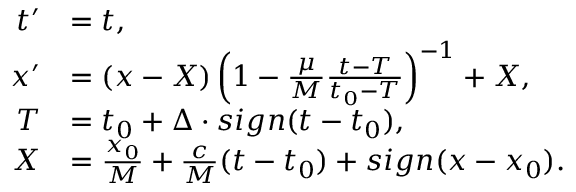Convert formula to latex. <formula><loc_0><loc_0><loc_500><loc_500>\begin{array} { r l } { t ^ { \prime } } & { = t , } \\ { x ^ { \prime } } & { = \left ( x - X \right ) \left ( 1 - \frac { \mu } { M } \frac { t - T } { t _ { 0 } - T } \right ) ^ { - 1 } + X , } \\ { T } & { = t _ { 0 } + \Delta \cdot s i g n ( t - t _ { 0 } ) , } \\ { X } & { = \frac { x _ { 0 } } { M } + \frac { c } { M } ( t - t _ { 0 } ) + s i g n ( x - x _ { 0 } ) . } \end{array}</formula> 